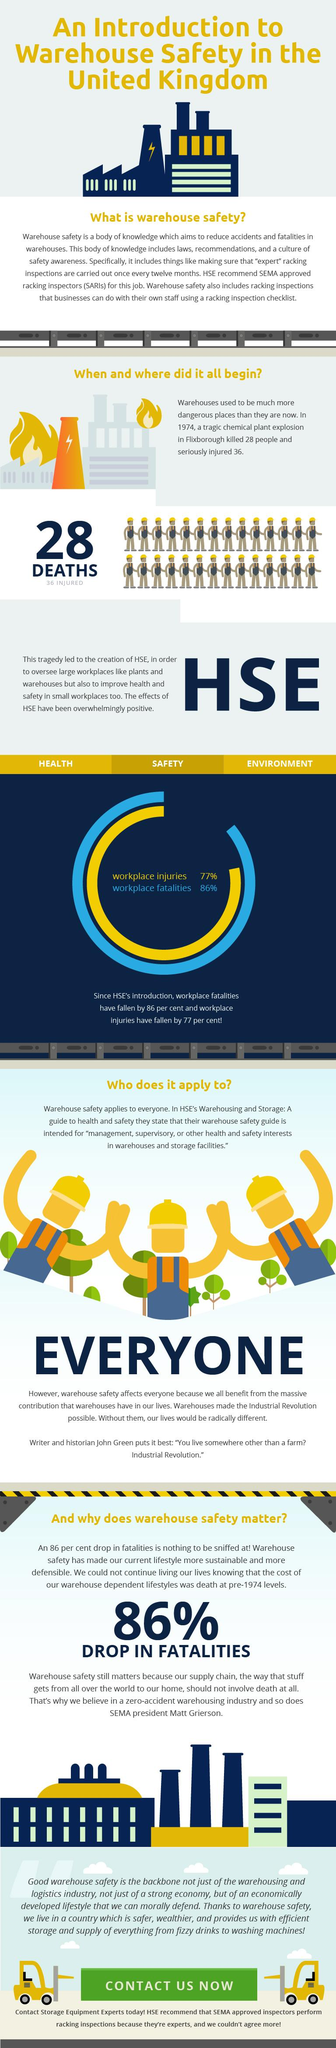Highlight a few significant elements in this photo. The infographic contains two rows of people. The disaster in Flixborough has been named. 